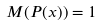Convert formula to latex. <formula><loc_0><loc_0><loc_500><loc_500>M ( P ( x ) ) = 1</formula> 